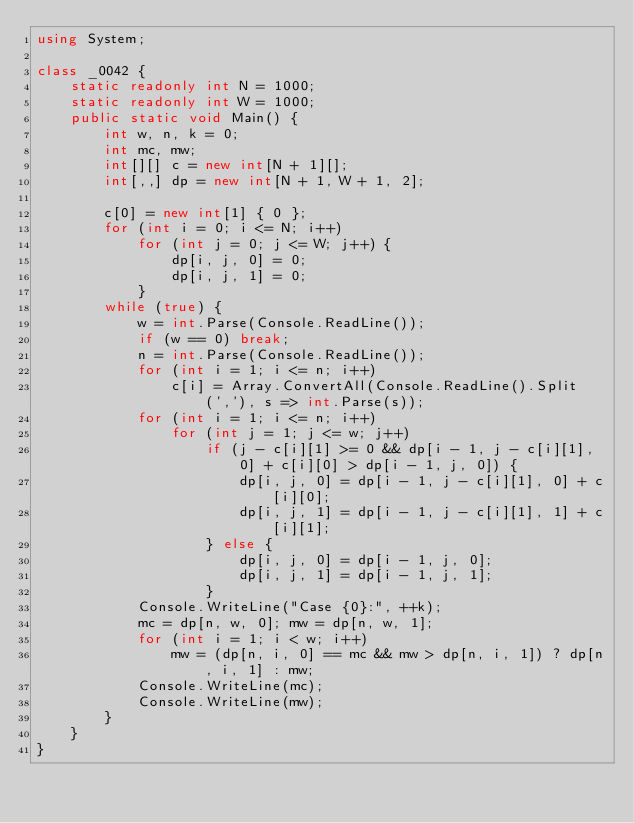<code> <loc_0><loc_0><loc_500><loc_500><_C#_>using System;

class _0042 {
    static readonly int N = 1000;
    static readonly int W = 1000;
    public static void Main() {
        int w, n, k = 0;
        int mc, mw;
        int[][] c = new int[N + 1][];
        int[,,] dp = new int[N + 1, W + 1, 2];

        c[0] = new int[1] { 0 };
        for (int i = 0; i <= N; i++)
            for (int j = 0; j <= W; j++) {
                dp[i, j, 0] = 0;
                dp[i, j, 1] = 0;
            }
        while (true) {
            w = int.Parse(Console.ReadLine());
            if (w == 0) break;
            n = int.Parse(Console.ReadLine());
            for (int i = 1; i <= n; i++)
                c[i] = Array.ConvertAll(Console.ReadLine().Split(','), s => int.Parse(s));
            for (int i = 1; i <= n; i++)
                for (int j = 1; j <= w; j++)
                    if (j - c[i][1] >= 0 && dp[i - 1, j - c[i][1], 0] + c[i][0] > dp[i - 1, j, 0]) {
                        dp[i, j, 0] = dp[i - 1, j - c[i][1], 0] + c[i][0];
                        dp[i, j, 1] = dp[i - 1, j - c[i][1], 1] + c[i][1];
                    } else {
                        dp[i, j, 0] = dp[i - 1, j, 0];
                        dp[i, j, 1] = dp[i - 1, j, 1];
                    }
            Console.WriteLine("Case {0}:", ++k);
            mc = dp[n, w, 0]; mw = dp[n, w, 1];
            for (int i = 1; i < w; i++)
                mw = (dp[n, i, 0] == mc && mw > dp[n, i, 1]) ? dp[n, i, 1] : mw;
            Console.WriteLine(mc);
            Console.WriteLine(mw);
        }
    }
}</code> 